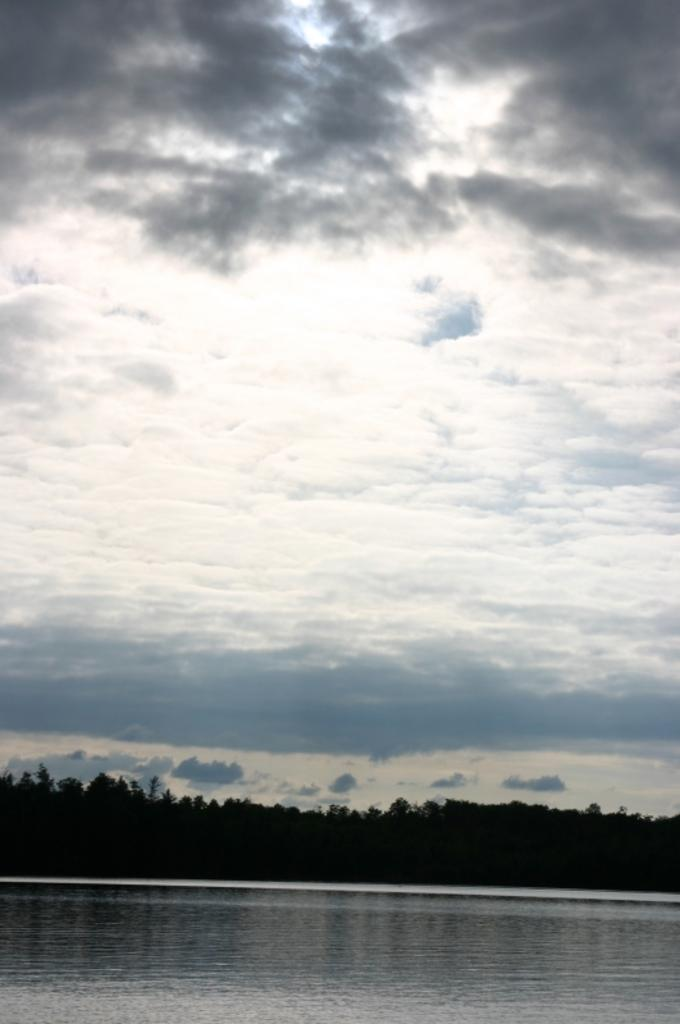What is at the bottom of the image? There is water at the bottom of the image. What can be seen in the middle of the image? There are trees in the middle of the image. What is visible at the top of the image? Clouds and sky are visible at the top of the image. What type of soup is being served in the image? There is no soup present in the image; it features water, trees, clouds, and sky. How many cents are visible in the image? There are no cents present in the image. 